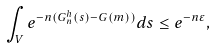<formula> <loc_0><loc_0><loc_500><loc_500>\int _ { V } { e ^ { - n ( G _ { n } ^ { h } ( s ) - G ( m ) ) } d s } \leq e ^ { - n \varepsilon } ,</formula> 